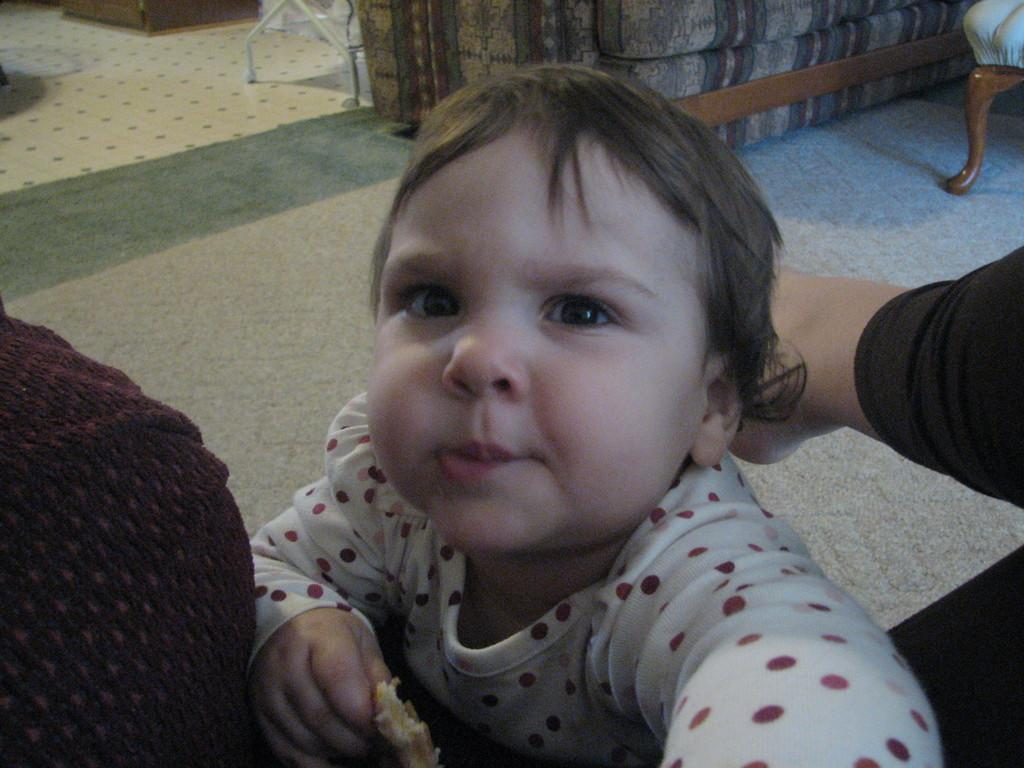What is the main subject of the image? There is a baby in the image. What is the baby wearing? The baby is wearing a white shirt. Can you describe the object in front of the baby? There is an object in maroon color in front of the baby. What can be seen in the background of the image? There is a couch and a table in the background of the image. What type of curtain is hanging on the window in the image? There is no window or curtain present in the image. What riddle can be solved by looking at the baby in the image? There is no riddle associated with the baby in the image. 